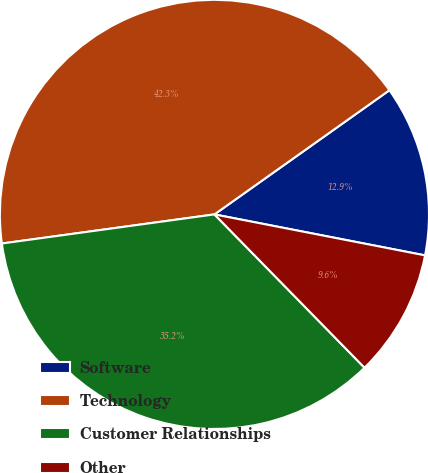Convert chart to OTSL. <chart><loc_0><loc_0><loc_500><loc_500><pie_chart><fcel>Software<fcel>Technology<fcel>Customer Relationships<fcel>Other<nl><fcel>12.88%<fcel>42.34%<fcel>35.16%<fcel>9.61%<nl></chart> 